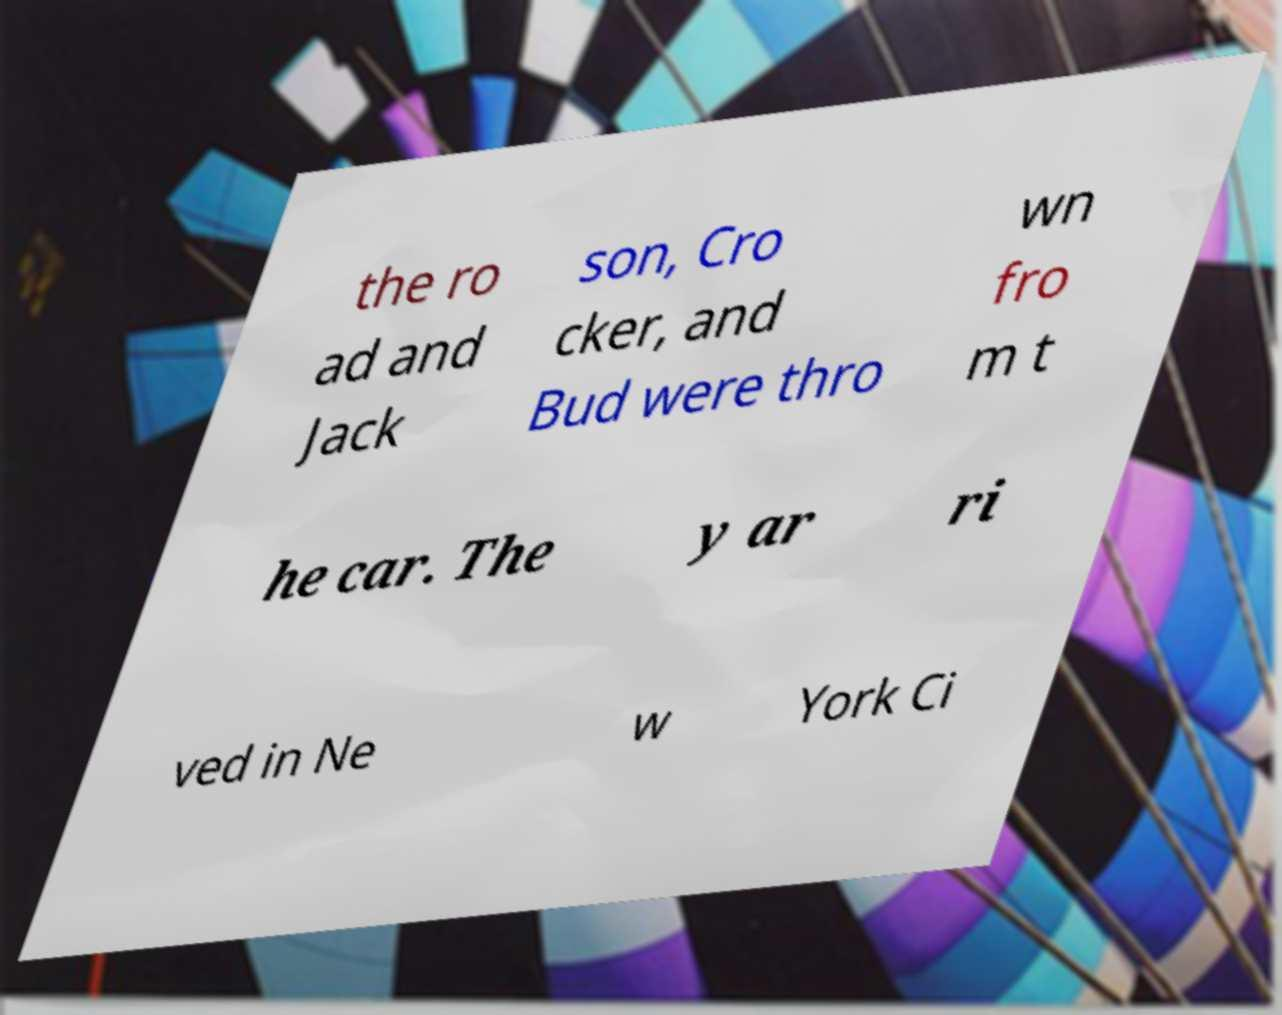Please identify and transcribe the text found in this image. the ro ad and Jack son, Cro cker, and Bud were thro wn fro m t he car. The y ar ri ved in Ne w York Ci 